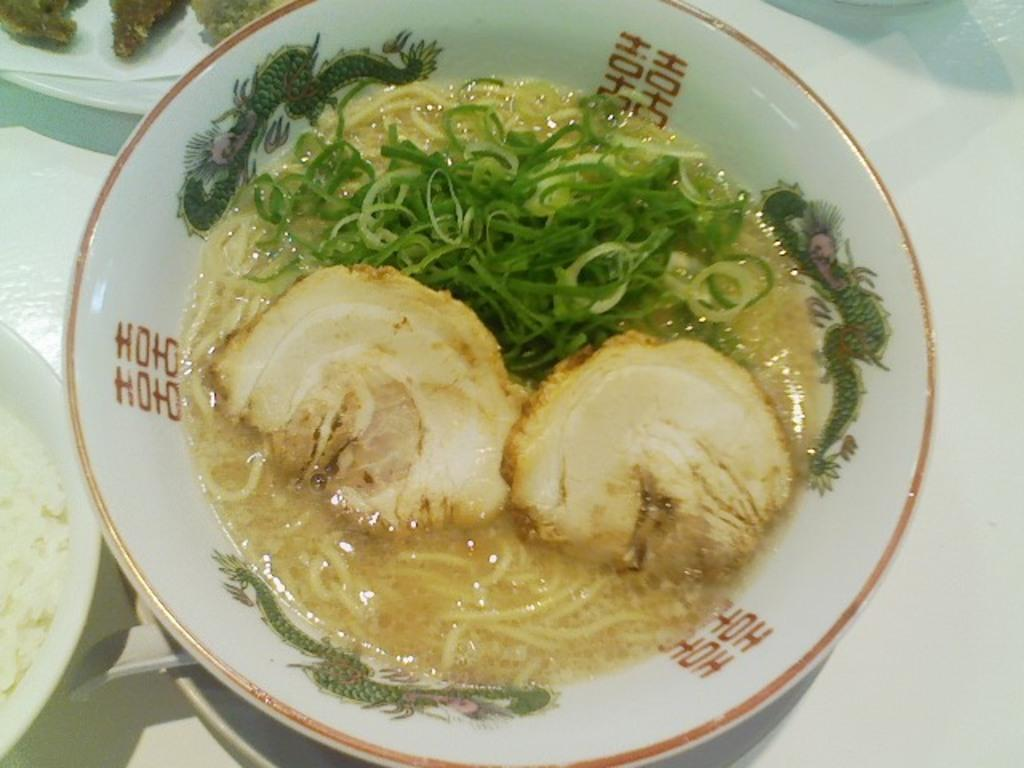What is on the plate that is in the middle of the image? There is a food item on a plate in the image. Where is the plate located in the image? The plate is in the middle of the image. On what surface is the plate placed? The plate is on a surface. What can be seen on the left side of the image? There is another plate on the left side of the image. What type of seed is being planted in the image? There is no seed or planting activity present in the image. How does the rain affect the food item on the plate in the image? There is no rain present in the image, so it cannot affect the food item on the plate. 